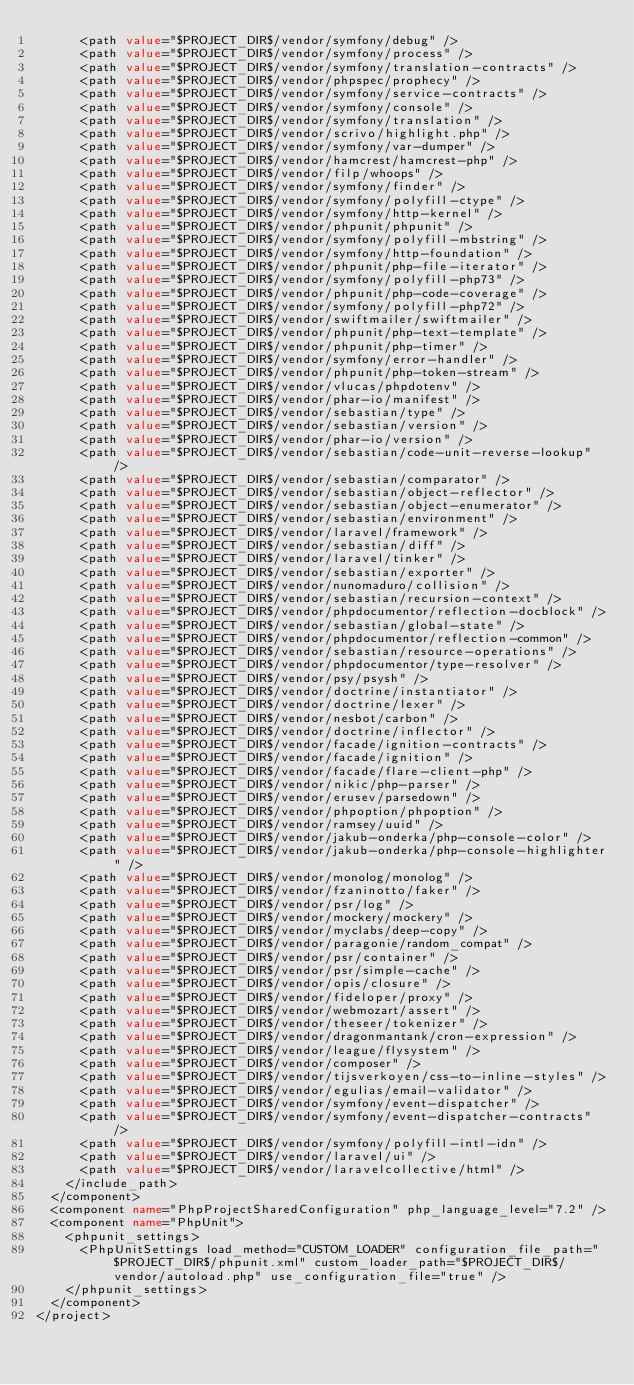<code> <loc_0><loc_0><loc_500><loc_500><_XML_>      <path value="$PROJECT_DIR$/vendor/symfony/debug" />
      <path value="$PROJECT_DIR$/vendor/symfony/process" />
      <path value="$PROJECT_DIR$/vendor/symfony/translation-contracts" />
      <path value="$PROJECT_DIR$/vendor/phpspec/prophecy" />
      <path value="$PROJECT_DIR$/vendor/symfony/service-contracts" />
      <path value="$PROJECT_DIR$/vendor/symfony/console" />
      <path value="$PROJECT_DIR$/vendor/symfony/translation" />
      <path value="$PROJECT_DIR$/vendor/scrivo/highlight.php" />
      <path value="$PROJECT_DIR$/vendor/symfony/var-dumper" />
      <path value="$PROJECT_DIR$/vendor/hamcrest/hamcrest-php" />
      <path value="$PROJECT_DIR$/vendor/filp/whoops" />
      <path value="$PROJECT_DIR$/vendor/symfony/finder" />
      <path value="$PROJECT_DIR$/vendor/symfony/polyfill-ctype" />
      <path value="$PROJECT_DIR$/vendor/symfony/http-kernel" />
      <path value="$PROJECT_DIR$/vendor/phpunit/phpunit" />
      <path value="$PROJECT_DIR$/vendor/symfony/polyfill-mbstring" />
      <path value="$PROJECT_DIR$/vendor/symfony/http-foundation" />
      <path value="$PROJECT_DIR$/vendor/phpunit/php-file-iterator" />
      <path value="$PROJECT_DIR$/vendor/symfony/polyfill-php73" />
      <path value="$PROJECT_DIR$/vendor/phpunit/php-code-coverage" />
      <path value="$PROJECT_DIR$/vendor/symfony/polyfill-php72" />
      <path value="$PROJECT_DIR$/vendor/swiftmailer/swiftmailer" />
      <path value="$PROJECT_DIR$/vendor/phpunit/php-text-template" />
      <path value="$PROJECT_DIR$/vendor/phpunit/php-timer" />
      <path value="$PROJECT_DIR$/vendor/symfony/error-handler" />
      <path value="$PROJECT_DIR$/vendor/phpunit/php-token-stream" />
      <path value="$PROJECT_DIR$/vendor/vlucas/phpdotenv" />
      <path value="$PROJECT_DIR$/vendor/phar-io/manifest" />
      <path value="$PROJECT_DIR$/vendor/sebastian/type" />
      <path value="$PROJECT_DIR$/vendor/sebastian/version" />
      <path value="$PROJECT_DIR$/vendor/phar-io/version" />
      <path value="$PROJECT_DIR$/vendor/sebastian/code-unit-reverse-lookup" />
      <path value="$PROJECT_DIR$/vendor/sebastian/comparator" />
      <path value="$PROJECT_DIR$/vendor/sebastian/object-reflector" />
      <path value="$PROJECT_DIR$/vendor/sebastian/object-enumerator" />
      <path value="$PROJECT_DIR$/vendor/sebastian/environment" />
      <path value="$PROJECT_DIR$/vendor/laravel/framework" />
      <path value="$PROJECT_DIR$/vendor/sebastian/diff" />
      <path value="$PROJECT_DIR$/vendor/laravel/tinker" />
      <path value="$PROJECT_DIR$/vendor/sebastian/exporter" />
      <path value="$PROJECT_DIR$/vendor/nunomaduro/collision" />
      <path value="$PROJECT_DIR$/vendor/sebastian/recursion-context" />
      <path value="$PROJECT_DIR$/vendor/phpdocumentor/reflection-docblock" />
      <path value="$PROJECT_DIR$/vendor/sebastian/global-state" />
      <path value="$PROJECT_DIR$/vendor/phpdocumentor/reflection-common" />
      <path value="$PROJECT_DIR$/vendor/sebastian/resource-operations" />
      <path value="$PROJECT_DIR$/vendor/phpdocumentor/type-resolver" />
      <path value="$PROJECT_DIR$/vendor/psy/psysh" />
      <path value="$PROJECT_DIR$/vendor/doctrine/instantiator" />
      <path value="$PROJECT_DIR$/vendor/doctrine/lexer" />
      <path value="$PROJECT_DIR$/vendor/nesbot/carbon" />
      <path value="$PROJECT_DIR$/vendor/doctrine/inflector" />
      <path value="$PROJECT_DIR$/vendor/facade/ignition-contracts" />
      <path value="$PROJECT_DIR$/vendor/facade/ignition" />
      <path value="$PROJECT_DIR$/vendor/facade/flare-client-php" />
      <path value="$PROJECT_DIR$/vendor/nikic/php-parser" />
      <path value="$PROJECT_DIR$/vendor/erusev/parsedown" />
      <path value="$PROJECT_DIR$/vendor/phpoption/phpoption" />
      <path value="$PROJECT_DIR$/vendor/ramsey/uuid" />
      <path value="$PROJECT_DIR$/vendor/jakub-onderka/php-console-color" />
      <path value="$PROJECT_DIR$/vendor/jakub-onderka/php-console-highlighter" />
      <path value="$PROJECT_DIR$/vendor/monolog/monolog" />
      <path value="$PROJECT_DIR$/vendor/fzaninotto/faker" />
      <path value="$PROJECT_DIR$/vendor/psr/log" />
      <path value="$PROJECT_DIR$/vendor/mockery/mockery" />
      <path value="$PROJECT_DIR$/vendor/myclabs/deep-copy" />
      <path value="$PROJECT_DIR$/vendor/paragonie/random_compat" />
      <path value="$PROJECT_DIR$/vendor/psr/container" />
      <path value="$PROJECT_DIR$/vendor/psr/simple-cache" />
      <path value="$PROJECT_DIR$/vendor/opis/closure" />
      <path value="$PROJECT_DIR$/vendor/fideloper/proxy" />
      <path value="$PROJECT_DIR$/vendor/webmozart/assert" />
      <path value="$PROJECT_DIR$/vendor/theseer/tokenizer" />
      <path value="$PROJECT_DIR$/vendor/dragonmantank/cron-expression" />
      <path value="$PROJECT_DIR$/vendor/league/flysystem" />
      <path value="$PROJECT_DIR$/vendor/composer" />
      <path value="$PROJECT_DIR$/vendor/tijsverkoyen/css-to-inline-styles" />
      <path value="$PROJECT_DIR$/vendor/egulias/email-validator" />
      <path value="$PROJECT_DIR$/vendor/symfony/event-dispatcher" />
      <path value="$PROJECT_DIR$/vendor/symfony/event-dispatcher-contracts" />
      <path value="$PROJECT_DIR$/vendor/symfony/polyfill-intl-idn" />
      <path value="$PROJECT_DIR$/vendor/laravel/ui" />
      <path value="$PROJECT_DIR$/vendor/laravelcollective/html" />
    </include_path>
  </component>
  <component name="PhpProjectSharedConfiguration" php_language_level="7.2" />
  <component name="PhpUnit">
    <phpunit_settings>
      <PhpUnitSettings load_method="CUSTOM_LOADER" configuration_file_path="$PROJECT_DIR$/phpunit.xml" custom_loader_path="$PROJECT_DIR$/vendor/autoload.php" use_configuration_file="true" />
    </phpunit_settings>
  </component>
</project></code> 